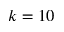Convert formula to latex. <formula><loc_0><loc_0><loc_500><loc_500>k = 1 0</formula> 